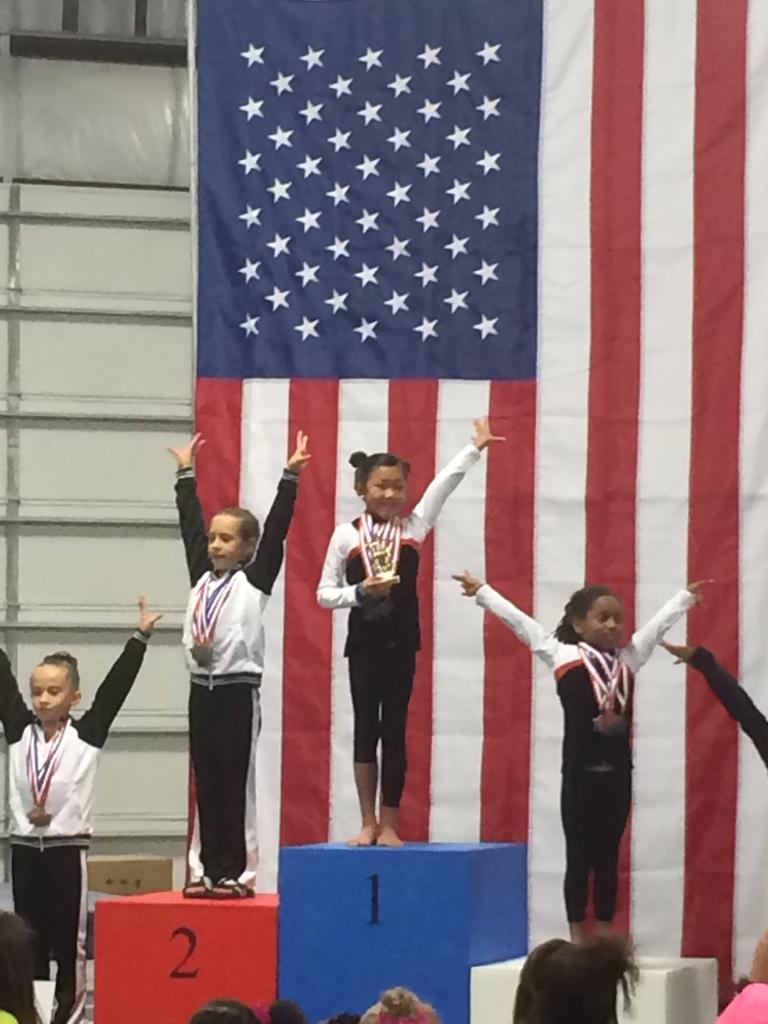What can be seen in the image? There are kids in the image. What are the kids doing in the image? The kids are standing on cubes. What are the kids wearing in the image? The kids are wearing medals around their necks. What else is visible in the image? There is a flag visible in the image. Can you tell me how many times the kids have to pull the rope in the image? There is no rope present in the image, so it is not possible to determine how many times the kids would need to pull it. 